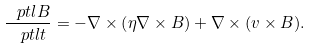Convert formula to latex. <formula><loc_0><loc_0><loc_500><loc_500>\frac { \ p t l { B } } { \ p t l t } = - \nabla \times \left ( \eta \nabla \times { B } \right ) + \nabla \times ( { v } \times { B } ) .</formula> 